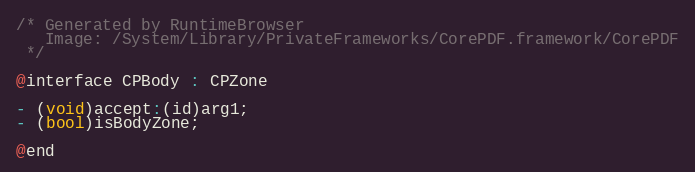<code> <loc_0><loc_0><loc_500><loc_500><_C_>/* Generated by RuntimeBrowser
   Image: /System/Library/PrivateFrameworks/CorePDF.framework/CorePDF
 */

@interface CPBody : CPZone

- (void)accept:(id)arg1;
- (bool)isBodyZone;

@end
</code> 